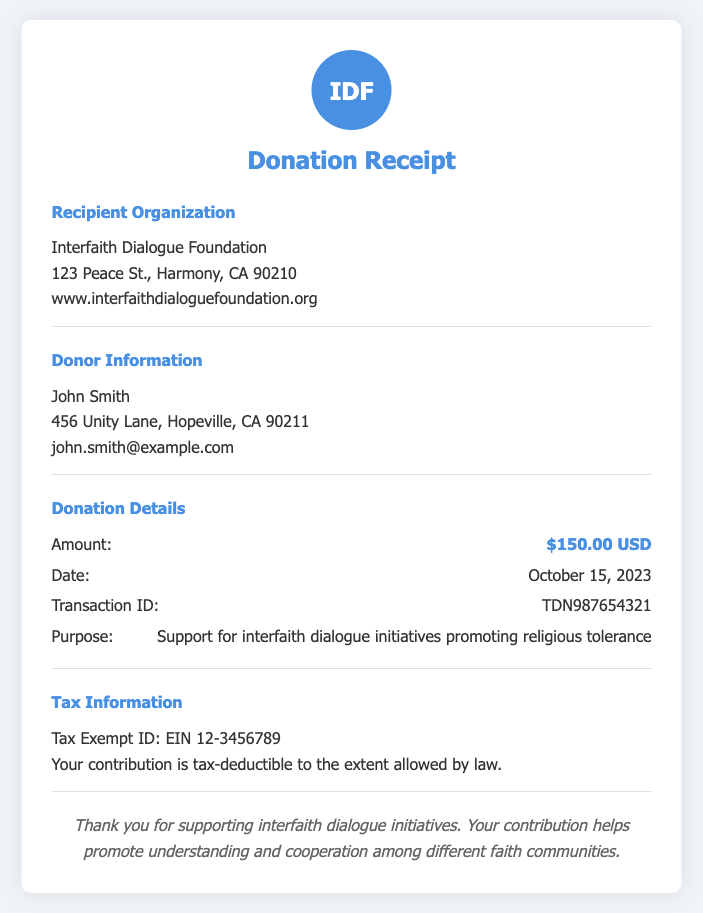What is the amount of the donation? The amount of the donation is specified in the Donation Details section of the document.
Answer: $150.00 USD Who is the recipient organization? The recipient organization is mentioned in the Recipient Organization section of the document.
Answer: Interfaith Dialogue Foundation What is the date of the donation? The date of the donation is provided in the Donation Details section.
Answer: October 15, 2023 What is the Transaction ID? The Transaction ID is listed in the Donation Details section, which is a unique identifier for the donation.
Answer: TDN987654321 What is the purpose of the donation? The purpose of the donation is specified in the Donation Details section of the document.
Answer: Support for interfaith dialogue initiatives promoting religious tolerance Who is the donor? The donor's name is found in the Donor Information section of the document.
Answer: John Smith What is the Tax Exempt ID? The Tax Exempt ID can be found in the Tax Information section, identifying the organization for tax purposes.
Answer: EIN 12-3456789 What does the document indicate about the tax-deductibility of the donation? The document provides information about the tax-deductibility related to the donation in the Tax Information section.
Answer: Tax-deductible to the extent allowed by law What message does the receipt convey at the end? The final section contains a thank-you message expressing the impact of the contribution.
Answer: Thank you for supporting interfaith dialogue initiatives. Your contribution helps promote understanding and cooperation among different faith communities 